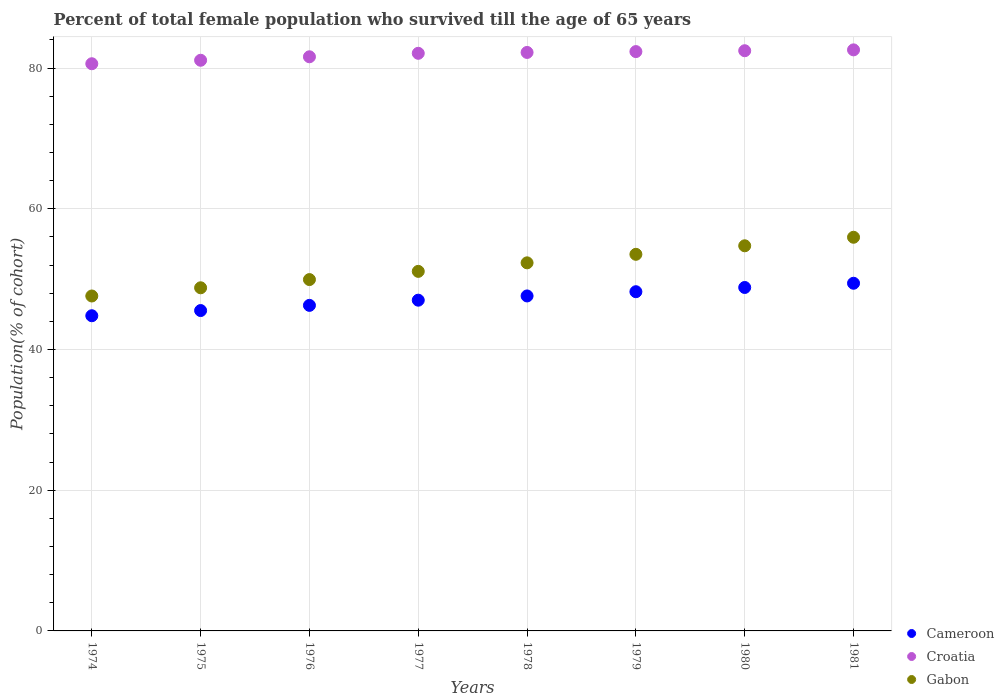Is the number of dotlines equal to the number of legend labels?
Offer a very short reply. Yes. What is the percentage of total female population who survived till the age of 65 years in Gabon in 1977?
Ensure brevity in your answer.  51.11. Across all years, what is the maximum percentage of total female population who survived till the age of 65 years in Gabon?
Your response must be concise. 55.96. Across all years, what is the minimum percentage of total female population who survived till the age of 65 years in Cameroon?
Offer a terse response. 44.8. In which year was the percentage of total female population who survived till the age of 65 years in Gabon maximum?
Give a very brief answer. 1981. In which year was the percentage of total female population who survived till the age of 65 years in Gabon minimum?
Ensure brevity in your answer.  1974. What is the total percentage of total female population who survived till the age of 65 years in Gabon in the graph?
Ensure brevity in your answer.  413.98. What is the difference between the percentage of total female population who survived till the age of 65 years in Croatia in 1978 and that in 1981?
Your response must be concise. -0.37. What is the difference between the percentage of total female population who survived till the age of 65 years in Croatia in 1975 and the percentage of total female population who survived till the age of 65 years in Cameroon in 1977?
Make the answer very short. 34.1. What is the average percentage of total female population who survived till the age of 65 years in Gabon per year?
Keep it short and to the point. 51.75. In the year 1978, what is the difference between the percentage of total female population who survived till the age of 65 years in Croatia and percentage of total female population who survived till the age of 65 years in Cameroon?
Your response must be concise. 34.61. What is the ratio of the percentage of total female population who survived till the age of 65 years in Cameroon in 1976 to that in 1981?
Provide a succinct answer. 0.94. Is the percentage of total female population who survived till the age of 65 years in Cameroon in 1978 less than that in 1980?
Keep it short and to the point. Yes. Is the difference between the percentage of total female population who survived till the age of 65 years in Croatia in 1976 and 1981 greater than the difference between the percentage of total female population who survived till the age of 65 years in Cameroon in 1976 and 1981?
Keep it short and to the point. Yes. What is the difference between the highest and the second highest percentage of total female population who survived till the age of 65 years in Gabon?
Keep it short and to the point. 1.21. What is the difference between the highest and the lowest percentage of total female population who survived till the age of 65 years in Cameroon?
Keep it short and to the point. 4.62. Is the sum of the percentage of total female population who survived till the age of 65 years in Gabon in 1976 and 1979 greater than the maximum percentage of total female population who survived till the age of 65 years in Croatia across all years?
Give a very brief answer. Yes. Is it the case that in every year, the sum of the percentage of total female population who survived till the age of 65 years in Croatia and percentage of total female population who survived till the age of 65 years in Cameroon  is greater than the percentage of total female population who survived till the age of 65 years in Gabon?
Your response must be concise. Yes. Does the percentage of total female population who survived till the age of 65 years in Cameroon monotonically increase over the years?
Your response must be concise. Yes. Are the values on the major ticks of Y-axis written in scientific E-notation?
Make the answer very short. No. Does the graph contain any zero values?
Provide a short and direct response. No. Does the graph contain grids?
Ensure brevity in your answer.  Yes. Where does the legend appear in the graph?
Your answer should be compact. Bottom right. How many legend labels are there?
Your response must be concise. 3. How are the legend labels stacked?
Keep it short and to the point. Vertical. What is the title of the graph?
Your answer should be compact. Percent of total female population who survived till the age of 65 years. What is the label or title of the Y-axis?
Make the answer very short. Population(% of cohort). What is the Population(% of cohort) in Cameroon in 1974?
Provide a succinct answer. 44.8. What is the Population(% of cohort) of Croatia in 1974?
Keep it short and to the point. 80.62. What is the Population(% of cohort) of Gabon in 1974?
Provide a succinct answer. 47.61. What is the Population(% of cohort) of Cameroon in 1975?
Keep it short and to the point. 45.54. What is the Population(% of cohort) of Croatia in 1975?
Offer a terse response. 81.11. What is the Population(% of cohort) in Gabon in 1975?
Your answer should be very brief. 48.77. What is the Population(% of cohort) in Cameroon in 1976?
Provide a short and direct response. 46.27. What is the Population(% of cohort) in Croatia in 1976?
Give a very brief answer. 81.61. What is the Population(% of cohort) in Gabon in 1976?
Keep it short and to the point. 49.94. What is the Population(% of cohort) in Cameroon in 1977?
Your answer should be compact. 47.01. What is the Population(% of cohort) of Croatia in 1977?
Provide a short and direct response. 82.1. What is the Population(% of cohort) in Gabon in 1977?
Offer a terse response. 51.11. What is the Population(% of cohort) in Cameroon in 1978?
Your answer should be compact. 47.61. What is the Population(% of cohort) in Croatia in 1978?
Provide a succinct answer. 82.23. What is the Population(% of cohort) in Gabon in 1978?
Make the answer very short. 52.32. What is the Population(% of cohort) in Cameroon in 1979?
Your response must be concise. 48.22. What is the Population(% of cohort) of Croatia in 1979?
Give a very brief answer. 82.35. What is the Population(% of cohort) in Gabon in 1979?
Offer a terse response. 53.53. What is the Population(% of cohort) of Cameroon in 1980?
Offer a terse response. 48.82. What is the Population(% of cohort) of Croatia in 1980?
Make the answer very short. 82.47. What is the Population(% of cohort) in Gabon in 1980?
Keep it short and to the point. 54.74. What is the Population(% of cohort) of Cameroon in 1981?
Offer a very short reply. 49.42. What is the Population(% of cohort) of Croatia in 1981?
Make the answer very short. 82.59. What is the Population(% of cohort) in Gabon in 1981?
Keep it short and to the point. 55.96. Across all years, what is the maximum Population(% of cohort) of Cameroon?
Offer a terse response. 49.42. Across all years, what is the maximum Population(% of cohort) in Croatia?
Your answer should be compact. 82.59. Across all years, what is the maximum Population(% of cohort) in Gabon?
Make the answer very short. 55.96. Across all years, what is the minimum Population(% of cohort) of Cameroon?
Keep it short and to the point. 44.8. Across all years, what is the minimum Population(% of cohort) in Croatia?
Provide a succinct answer. 80.62. Across all years, what is the minimum Population(% of cohort) of Gabon?
Offer a terse response. 47.61. What is the total Population(% of cohort) of Cameroon in the graph?
Ensure brevity in your answer.  377.69. What is the total Population(% of cohort) in Croatia in the graph?
Your answer should be very brief. 655.08. What is the total Population(% of cohort) in Gabon in the graph?
Give a very brief answer. 413.98. What is the difference between the Population(% of cohort) of Cameroon in 1974 and that in 1975?
Ensure brevity in your answer.  -0.74. What is the difference between the Population(% of cohort) of Croatia in 1974 and that in 1975?
Keep it short and to the point. -0.49. What is the difference between the Population(% of cohort) of Gabon in 1974 and that in 1975?
Offer a terse response. -1.17. What is the difference between the Population(% of cohort) of Cameroon in 1974 and that in 1976?
Provide a succinct answer. -1.47. What is the difference between the Population(% of cohort) of Croatia in 1974 and that in 1976?
Give a very brief answer. -0.99. What is the difference between the Population(% of cohort) of Gabon in 1974 and that in 1976?
Make the answer very short. -2.33. What is the difference between the Population(% of cohort) of Cameroon in 1974 and that in 1977?
Your response must be concise. -2.21. What is the difference between the Population(% of cohort) in Croatia in 1974 and that in 1977?
Provide a short and direct response. -1.48. What is the difference between the Population(% of cohort) of Gabon in 1974 and that in 1977?
Make the answer very short. -3.5. What is the difference between the Population(% of cohort) in Cameroon in 1974 and that in 1978?
Give a very brief answer. -2.81. What is the difference between the Population(% of cohort) in Croatia in 1974 and that in 1978?
Provide a short and direct response. -1.61. What is the difference between the Population(% of cohort) of Gabon in 1974 and that in 1978?
Offer a terse response. -4.71. What is the difference between the Population(% of cohort) of Cameroon in 1974 and that in 1979?
Give a very brief answer. -3.42. What is the difference between the Population(% of cohort) of Croatia in 1974 and that in 1979?
Provide a short and direct response. -1.73. What is the difference between the Population(% of cohort) of Gabon in 1974 and that in 1979?
Make the answer very short. -5.92. What is the difference between the Population(% of cohort) in Cameroon in 1974 and that in 1980?
Ensure brevity in your answer.  -4.02. What is the difference between the Population(% of cohort) of Croatia in 1974 and that in 1980?
Offer a very short reply. -1.85. What is the difference between the Population(% of cohort) in Gabon in 1974 and that in 1980?
Offer a terse response. -7.14. What is the difference between the Population(% of cohort) in Cameroon in 1974 and that in 1981?
Your answer should be very brief. -4.62. What is the difference between the Population(% of cohort) in Croatia in 1974 and that in 1981?
Offer a terse response. -1.97. What is the difference between the Population(% of cohort) of Gabon in 1974 and that in 1981?
Provide a short and direct response. -8.35. What is the difference between the Population(% of cohort) of Cameroon in 1975 and that in 1976?
Provide a succinct answer. -0.74. What is the difference between the Population(% of cohort) in Croatia in 1975 and that in 1976?
Your answer should be compact. -0.49. What is the difference between the Population(% of cohort) of Gabon in 1975 and that in 1976?
Your answer should be compact. -1.17. What is the difference between the Population(% of cohort) in Cameroon in 1975 and that in 1977?
Your response must be concise. -1.47. What is the difference between the Population(% of cohort) in Croatia in 1975 and that in 1977?
Your answer should be compact. -0.99. What is the difference between the Population(% of cohort) of Gabon in 1975 and that in 1977?
Ensure brevity in your answer.  -2.33. What is the difference between the Population(% of cohort) of Cameroon in 1975 and that in 1978?
Make the answer very short. -2.08. What is the difference between the Population(% of cohort) of Croatia in 1975 and that in 1978?
Your answer should be compact. -1.11. What is the difference between the Population(% of cohort) of Gabon in 1975 and that in 1978?
Make the answer very short. -3.55. What is the difference between the Population(% of cohort) of Cameroon in 1975 and that in 1979?
Provide a succinct answer. -2.68. What is the difference between the Population(% of cohort) in Croatia in 1975 and that in 1979?
Offer a terse response. -1.23. What is the difference between the Population(% of cohort) of Gabon in 1975 and that in 1979?
Provide a short and direct response. -4.76. What is the difference between the Population(% of cohort) in Cameroon in 1975 and that in 1980?
Your answer should be very brief. -3.28. What is the difference between the Population(% of cohort) of Croatia in 1975 and that in 1980?
Provide a succinct answer. -1.36. What is the difference between the Population(% of cohort) in Gabon in 1975 and that in 1980?
Keep it short and to the point. -5.97. What is the difference between the Population(% of cohort) in Cameroon in 1975 and that in 1981?
Provide a short and direct response. -3.88. What is the difference between the Population(% of cohort) of Croatia in 1975 and that in 1981?
Provide a short and direct response. -1.48. What is the difference between the Population(% of cohort) of Gabon in 1975 and that in 1981?
Keep it short and to the point. -7.18. What is the difference between the Population(% of cohort) of Cameroon in 1976 and that in 1977?
Give a very brief answer. -0.74. What is the difference between the Population(% of cohort) in Croatia in 1976 and that in 1977?
Make the answer very short. -0.49. What is the difference between the Population(% of cohort) of Gabon in 1976 and that in 1977?
Your response must be concise. -1.17. What is the difference between the Population(% of cohort) of Cameroon in 1976 and that in 1978?
Ensure brevity in your answer.  -1.34. What is the difference between the Population(% of cohort) in Croatia in 1976 and that in 1978?
Your response must be concise. -0.62. What is the difference between the Population(% of cohort) in Gabon in 1976 and that in 1978?
Your answer should be very brief. -2.38. What is the difference between the Population(% of cohort) of Cameroon in 1976 and that in 1979?
Your answer should be compact. -1.94. What is the difference between the Population(% of cohort) of Croatia in 1976 and that in 1979?
Your answer should be compact. -0.74. What is the difference between the Population(% of cohort) of Gabon in 1976 and that in 1979?
Ensure brevity in your answer.  -3.59. What is the difference between the Population(% of cohort) in Cameroon in 1976 and that in 1980?
Provide a succinct answer. -2.54. What is the difference between the Population(% of cohort) of Croatia in 1976 and that in 1980?
Your answer should be very brief. -0.86. What is the difference between the Population(% of cohort) of Gabon in 1976 and that in 1980?
Provide a succinct answer. -4.8. What is the difference between the Population(% of cohort) in Cameroon in 1976 and that in 1981?
Offer a very short reply. -3.14. What is the difference between the Population(% of cohort) in Croatia in 1976 and that in 1981?
Your answer should be compact. -0.98. What is the difference between the Population(% of cohort) in Gabon in 1976 and that in 1981?
Ensure brevity in your answer.  -6.01. What is the difference between the Population(% of cohort) of Cameroon in 1977 and that in 1978?
Offer a terse response. -0.6. What is the difference between the Population(% of cohort) of Croatia in 1977 and that in 1978?
Ensure brevity in your answer.  -0.12. What is the difference between the Population(% of cohort) of Gabon in 1977 and that in 1978?
Your answer should be compact. -1.21. What is the difference between the Population(% of cohort) of Cameroon in 1977 and that in 1979?
Your response must be concise. -1.2. What is the difference between the Population(% of cohort) in Croatia in 1977 and that in 1979?
Your response must be concise. -0.24. What is the difference between the Population(% of cohort) in Gabon in 1977 and that in 1979?
Provide a succinct answer. -2.42. What is the difference between the Population(% of cohort) of Cameroon in 1977 and that in 1980?
Your response must be concise. -1.8. What is the difference between the Population(% of cohort) in Croatia in 1977 and that in 1980?
Keep it short and to the point. -0.37. What is the difference between the Population(% of cohort) of Gabon in 1977 and that in 1980?
Offer a terse response. -3.64. What is the difference between the Population(% of cohort) in Cameroon in 1977 and that in 1981?
Keep it short and to the point. -2.41. What is the difference between the Population(% of cohort) in Croatia in 1977 and that in 1981?
Ensure brevity in your answer.  -0.49. What is the difference between the Population(% of cohort) in Gabon in 1977 and that in 1981?
Give a very brief answer. -4.85. What is the difference between the Population(% of cohort) of Cameroon in 1978 and that in 1979?
Provide a succinct answer. -0.6. What is the difference between the Population(% of cohort) of Croatia in 1978 and that in 1979?
Provide a succinct answer. -0.12. What is the difference between the Population(% of cohort) of Gabon in 1978 and that in 1979?
Your answer should be compact. -1.21. What is the difference between the Population(% of cohort) in Cameroon in 1978 and that in 1980?
Keep it short and to the point. -1.2. What is the difference between the Population(% of cohort) of Croatia in 1978 and that in 1980?
Give a very brief answer. -0.24. What is the difference between the Population(% of cohort) of Gabon in 1978 and that in 1980?
Your answer should be very brief. -2.42. What is the difference between the Population(% of cohort) in Cameroon in 1978 and that in 1981?
Make the answer very short. -1.8. What is the difference between the Population(% of cohort) in Croatia in 1978 and that in 1981?
Keep it short and to the point. -0.37. What is the difference between the Population(% of cohort) of Gabon in 1978 and that in 1981?
Provide a short and direct response. -3.64. What is the difference between the Population(% of cohort) in Cameroon in 1979 and that in 1980?
Your answer should be very brief. -0.6. What is the difference between the Population(% of cohort) in Croatia in 1979 and that in 1980?
Keep it short and to the point. -0.12. What is the difference between the Population(% of cohort) in Gabon in 1979 and that in 1980?
Your answer should be very brief. -1.21. What is the difference between the Population(% of cohort) in Cameroon in 1979 and that in 1981?
Ensure brevity in your answer.  -1.2. What is the difference between the Population(% of cohort) of Croatia in 1979 and that in 1981?
Give a very brief answer. -0.24. What is the difference between the Population(% of cohort) in Gabon in 1979 and that in 1981?
Keep it short and to the point. -2.42. What is the difference between the Population(% of cohort) of Cameroon in 1980 and that in 1981?
Offer a very short reply. -0.6. What is the difference between the Population(% of cohort) in Croatia in 1980 and that in 1981?
Your answer should be very brief. -0.12. What is the difference between the Population(% of cohort) of Gabon in 1980 and that in 1981?
Give a very brief answer. -1.21. What is the difference between the Population(% of cohort) of Cameroon in 1974 and the Population(% of cohort) of Croatia in 1975?
Give a very brief answer. -36.31. What is the difference between the Population(% of cohort) in Cameroon in 1974 and the Population(% of cohort) in Gabon in 1975?
Offer a terse response. -3.97. What is the difference between the Population(% of cohort) of Croatia in 1974 and the Population(% of cohort) of Gabon in 1975?
Make the answer very short. 31.85. What is the difference between the Population(% of cohort) in Cameroon in 1974 and the Population(% of cohort) in Croatia in 1976?
Offer a very short reply. -36.81. What is the difference between the Population(% of cohort) in Cameroon in 1974 and the Population(% of cohort) in Gabon in 1976?
Make the answer very short. -5.14. What is the difference between the Population(% of cohort) of Croatia in 1974 and the Population(% of cohort) of Gabon in 1976?
Your response must be concise. 30.68. What is the difference between the Population(% of cohort) of Cameroon in 1974 and the Population(% of cohort) of Croatia in 1977?
Ensure brevity in your answer.  -37.3. What is the difference between the Population(% of cohort) of Cameroon in 1974 and the Population(% of cohort) of Gabon in 1977?
Your answer should be very brief. -6.31. What is the difference between the Population(% of cohort) of Croatia in 1974 and the Population(% of cohort) of Gabon in 1977?
Offer a terse response. 29.51. What is the difference between the Population(% of cohort) of Cameroon in 1974 and the Population(% of cohort) of Croatia in 1978?
Provide a succinct answer. -37.43. What is the difference between the Population(% of cohort) in Cameroon in 1974 and the Population(% of cohort) in Gabon in 1978?
Give a very brief answer. -7.52. What is the difference between the Population(% of cohort) in Croatia in 1974 and the Population(% of cohort) in Gabon in 1978?
Your answer should be very brief. 28.3. What is the difference between the Population(% of cohort) of Cameroon in 1974 and the Population(% of cohort) of Croatia in 1979?
Your answer should be compact. -37.55. What is the difference between the Population(% of cohort) of Cameroon in 1974 and the Population(% of cohort) of Gabon in 1979?
Your response must be concise. -8.73. What is the difference between the Population(% of cohort) in Croatia in 1974 and the Population(% of cohort) in Gabon in 1979?
Make the answer very short. 27.09. What is the difference between the Population(% of cohort) in Cameroon in 1974 and the Population(% of cohort) in Croatia in 1980?
Ensure brevity in your answer.  -37.67. What is the difference between the Population(% of cohort) in Cameroon in 1974 and the Population(% of cohort) in Gabon in 1980?
Your answer should be compact. -9.94. What is the difference between the Population(% of cohort) of Croatia in 1974 and the Population(% of cohort) of Gabon in 1980?
Offer a very short reply. 25.88. What is the difference between the Population(% of cohort) in Cameroon in 1974 and the Population(% of cohort) in Croatia in 1981?
Make the answer very short. -37.79. What is the difference between the Population(% of cohort) of Cameroon in 1974 and the Population(% of cohort) of Gabon in 1981?
Provide a short and direct response. -11.16. What is the difference between the Population(% of cohort) of Croatia in 1974 and the Population(% of cohort) of Gabon in 1981?
Give a very brief answer. 24.66. What is the difference between the Population(% of cohort) of Cameroon in 1975 and the Population(% of cohort) of Croatia in 1976?
Your answer should be very brief. -36.07. What is the difference between the Population(% of cohort) in Cameroon in 1975 and the Population(% of cohort) in Gabon in 1976?
Provide a short and direct response. -4.4. What is the difference between the Population(% of cohort) of Croatia in 1975 and the Population(% of cohort) of Gabon in 1976?
Keep it short and to the point. 31.17. What is the difference between the Population(% of cohort) in Cameroon in 1975 and the Population(% of cohort) in Croatia in 1977?
Offer a very short reply. -36.57. What is the difference between the Population(% of cohort) of Cameroon in 1975 and the Population(% of cohort) of Gabon in 1977?
Ensure brevity in your answer.  -5.57. What is the difference between the Population(% of cohort) in Croatia in 1975 and the Population(% of cohort) in Gabon in 1977?
Provide a succinct answer. 30.01. What is the difference between the Population(% of cohort) in Cameroon in 1975 and the Population(% of cohort) in Croatia in 1978?
Offer a very short reply. -36.69. What is the difference between the Population(% of cohort) in Cameroon in 1975 and the Population(% of cohort) in Gabon in 1978?
Give a very brief answer. -6.78. What is the difference between the Population(% of cohort) in Croatia in 1975 and the Population(% of cohort) in Gabon in 1978?
Ensure brevity in your answer.  28.8. What is the difference between the Population(% of cohort) of Cameroon in 1975 and the Population(% of cohort) of Croatia in 1979?
Provide a short and direct response. -36.81. What is the difference between the Population(% of cohort) of Cameroon in 1975 and the Population(% of cohort) of Gabon in 1979?
Provide a short and direct response. -7.99. What is the difference between the Population(% of cohort) in Croatia in 1975 and the Population(% of cohort) in Gabon in 1979?
Make the answer very short. 27.58. What is the difference between the Population(% of cohort) in Cameroon in 1975 and the Population(% of cohort) in Croatia in 1980?
Provide a succinct answer. -36.93. What is the difference between the Population(% of cohort) of Cameroon in 1975 and the Population(% of cohort) of Gabon in 1980?
Your answer should be compact. -9.21. What is the difference between the Population(% of cohort) of Croatia in 1975 and the Population(% of cohort) of Gabon in 1980?
Your answer should be very brief. 26.37. What is the difference between the Population(% of cohort) in Cameroon in 1975 and the Population(% of cohort) in Croatia in 1981?
Offer a very short reply. -37.05. What is the difference between the Population(% of cohort) in Cameroon in 1975 and the Population(% of cohort) in Gabon in 1981?
Keep it short and to the point. -10.42. What is the difference between the Population(% of cohort) of Croatia in 1975 and the Population(% of cohort) of Gabon in 1981?
Make the answer very short. 25.16. What is the difference between the Population(% of cohort) of Cameroon in 1976 and the Population(% of cohort) of Croatia in 1977?
Make the answer very short. -35.83. What is the difference between the Population(% of cohort) of Cameroon in 1976 and the Population(% of cohort) of Gabon in 1977?
Offer a very short reply. -4.83. What is the difference between the Population(% of cohort) in Croatia in 1976 and the Population(% of cohort) in Gabon in 1977?
Offer a very short reply. 30.5. What is the difference between the Population(% of cohort) of Cameroon in 1976 and the Population(% of cohort) of Croatia in 1978?
Your answer should be very brief. -35.95. What is the difference between the Population(% of cohort) of Cameroon in 1976 and the Population(% of cohort) of Gabon in 1978?
Ensure brevity in your answer.  -6.04. What is the difference between the Population(% of cohort) of Croatia in 1976 and the Population(% of cohort) of Gabon in 1978?
Ensure brevity in your answer.  29.29. What is the difference between the Population(% of cohort) in Cameroon in 1976 and the Population(% of cohort) in Croatia in 1979?
Provide a short and direct response. -36.07. What is the difference between the Population(% of cohort) of Cameroon in 1976 and the Population(% of cohort) of Gabon in 1979?
Keep it short and to the point. -7.26. What is the difference between the Population(% of cohort) of Croatia in 1976 and the Population(% of cohort) of Gabon in 1979?
Give a very brief answer. 28.08. What is the difference between the Population(% of cohort) of Cameroon in 1976 and the Population(% of cohort) of Croatia in 1980?
Provide a succinct answer. -36.2. What is the difference between the Population(% of cohort) in Cameroon in 1976 and the Population(% of cohort) in Gabon in 1980?
Give a very brief answer. -8.47. What is the difference between the Population(% of cohort) of Croatia in 1976 and the Population(% of cohort) of Gabon in 1980?
Offer a very short reply. 26.87. What is the difference between the Population(% of cohort) of Cameroon in 1976 and the Population(% of cohort) of Croatia in 1981?
Provide a succinct answer. -36.32. What is the difference between the Population(% of cohort) of Cameroon in 1976 and the Population(% of cohort) of Gabon in 1981?
Your answer should be compact. -9.68. What is the difference between the Population(% of cohort) of Croatia in 1976 and the Population(% of cohort) of Gabon in 1981?
Your response must be concise. 25.65. What is the difference between the Population(% of cohort) of Cameroon in 1977 and the Population(% of cohort) of Croatia in 1978?
Provide a succinct answer. -35.21. What is the difference between the Population(% of cohort) of Cameroon in 1977 and the Population(% of cohort) of Gabon in 1978?
Provide a succinct answer. -5.31. What is the difference between the Population(% of cohort) in Croatia in 1977 and the Population(% of cohort) in Gabon in 1978?
Your response must be concise. 29.78. What is the difference between the Population(% of cohort) in Cameroon in 1977 and the Population(% of cohort) in Croatia in 1979?
Offer a very short reply. -35.34. What is the difference between the Population(% of cohort) of Cameroon in 1977 and the Population(% of cohort) of Gabon in 1979?
Your answer should be very brief. -6.52. What is the difference between the Population(% of cohort) in Croatia in 1977 and the Population(% of cohort) in Gabon in 1979?
Your answer should be very brief. 28.57. What is the difference between the Population(% of cohort) of Cameroon in 1977 and the Population(% of cohort) of Croatia in 1980?
Offer a terse response. -35.46. What is the difference between the Population(% of cohort) in Cameroon in 1977 and the Population(% of cohort) in Gabon in 1980?
Keep it short and to the point. -7.73. What is the difference between the Population(% of cohort) of Croatia in 1977 and the Population(% of cohort) of Gabon in 1980?
Your answer should be very brief. 27.36. What is the difference between the Population(% of cohort) in Cameroon in 1977 and the Population(% of cohort) in Croatia in 1981?
Provide a short and direct response. -35.58. What is the difference between the Population(% of cohort) of Cameroon in 1977 and the Population(% of cohort) of Gabon in 1981?
Your answer should be compact. -8.94. What is the difference between the Population(% of cohort) in Croatia in 1977 and the Population(% of cohort) in Gabon in 1981?
Provide a succinct answer. 26.15. What is the difference between the Population(% of cohort) of Cameroon in 1978 and the Population(% of cohort) of Croatia in 1979?
Offer a terse response. -34.73. What is the difference between the Population(% of cohort) in Cameroon in 1978 and the Population(% of cohort) in Gabon in 1979?
Your answer should be compact. -5.92. What is the difference between the Population(% of cohort) in Croatia in 1978 and the Population(% of cohort) in Gabon in 1979?
Provide a succinct answer. 28.69. What is the difference between the Population(% of cohort) of Cameroon in 1978 and the Population(% of cohort) of Croatia in 1980?
Give a very brief answer. -34.86. What is the difference between the Population(% of cohort) of Cameroon in 1978 and the Population(% of cohort) of Gabon in 1980?
Your response must be concise. -7.13. What is the difference between the Population(% of cohort) in Croatia in 1978 and the Population(% of cohort) in Gabon in 1980?
Ensure brevity in your answer.  27.48. What is the difference between the Population(% of cohort) in Cameroon in 1978 and the Population(% of cohort) in Croatia in 1981?
Your answer should be very brief. -34.98. What is the difference between the Population(% of cohort) in Cameroon in 1978 and the Population(% of cohort) in Gabon in 1981?
Provide a succinct answer. -8.34. What is the difference between the Population(% of cohort) of Croatia in 1978 and the Population(% of cohort) of Gabon in 1981?
Keep it short and to the point. 26.27. What is the difference between the Population(% of cohort) of Cameroon in 1979 and the Population(% of cohort) of Croatia in 1980?
Your response must be concise. -34.25. What is the difference between the Population(% of cohort) in Cameroon in 1979 and the Population(% of cohort) in Gabon in 1980?
Ensure brevity in your answer.  -6.53. What is the difference between the Population(% of cohort) in Croatia in 1979 and the Population(% of cohort) in Gabon in 1980?
Your response must be concise. 27.6. What is the difference between the Population(% of cohort) of Cameroon in 1979 and the Population(% of cohort) of Croatia in 1981?
Provide a short and direct response. -34.38. What is the difference between the Population(% of cohort) in Cameroon in 1979 and the Population(% of cohort) in Gabon in 1981?
Provide a short and direct response. -7.74. What is the difference between the Population(% of cohort) of Croatia in 1979 and the Population(% of cohort) of Gabon in 1981?
Provide a short and direct response. 26.39. What is the difference between the Population(% of cohort) in Cameroon in 1980 and the Population(% of cohort) in Croatia in 1981?
Offer a terse response. -33.77. What is the difference between the Population(% of cohort) of Cameroon in 1980 and the Population(% of cohort) of Gabon in 1981?
Make the answer very short. -7.14. What is the difference between the Population(% of cohort) of Croatia in 1980 and the Population(% of cohort) of Gabon in 1981?
Provide a succinct answer. 26.51. What is the average Population(% of cohort) of Cameroon per year?
Provide a short and direct response. 47.21. What is the average Population(% of cohort) in Croatia per year?
Offer a terse response. 81.89. What is the average Population(% of cohort) in Gabon per year?
Keep it short and to the point. 51.75. In the year 1974, what is the difference between the Population(% of cohort) of Cameroon and Population(% of cohort) of Croatia?
Ensure brevity in your answer.  -35.82. In the year 1974, what is the difference between the Population(% of cohort) of Cameroon and Population(% of cohort) of Gabon?
Provide a short and direct response. -2.81. In the year 1974, what is the difference between the Population(% of cohort) of Croatia and Population(% of cohort) of Gabon?
Make the answer very short. 33.01. In the year 1975, what is the difference between the Population(% of cohort) of Cameroon and Population(% of cohort) of Croatia?
Ensure brevity in your answer.  -35.58. In the year 1975, what is the difference between the Population(% of cohort) of Cameroon and Population(% of cohort) of Gabon?
Keep it short and to the point. -3.24. In the year 1975, what is the difference between the Population(% of cohort) of Croatia and Population(% of cohort) of Gabon?
Keep it short and to the point. 32.34. In the year 1976, what is the difference between the Population(% of cohort) of Cameroon and Population(% of cohort) of Croatia?
Make the answer very short. -35.33. In the year 1976, what is the difference between the Population(% of cohort) in Cameroon and Population(% of cohort) in Gabon?
Your response must be concise. -3.67. In the year 1976, what is the difference between the Population(% of cohort) in Croatia and Population(% of cohort) in Gabon?
Offer a terse response. 31.67. In the year 1977, what is the difference between the Population(% of cohort) in Cameroon and Population(% of cohort) in Croatia?
Ensure brevity in your answer.  -35.09. In the year 1977, what is the difference between the Population(% of cohort) of Cameroon and Population(% of cohort) of Gabon?
Provide a short and direct response. -4.1. In the year 1977, what is the difference between the Population(% of cohort) in Croatia and Population(% of cohort) in Gabon?
Offer a terse response. 31. In the year 1978, what is the difference between the Population(% of cohort) in Cameroon and Population(% of cohort) in Croatia?
Offer a terse response. -34.61. In the year 1978, what is the difference between the Population(% of cohort) in Cameroon and Population(% of cohort) in Gabon?
Keep it short and to the point. -4.71. In the year 1978, what is the difference between the Population(% of cohort) of Croatia and Population(% of cohort) of Gabon?
Provide a short and direct response. 29.91. In the year 1979, what is the difference between the Population(% of cohort) in Cameroon and Population(% of cohort) in Croatia?
Give a very brief answer. -34.13. In the year 1979, what is the difference between the Population(% of cohort) in Cameroon and Population(% of cohort) in Gabon?
Keep it short and to the point. -5.32. In the year 1979, what is the difference between the Population(% of cohort) of Croatia and Population(% of cohort) of Gabon?
Your answer should be very brief. 28.82. In the year 1980, what is the difference between the Population(% of cohort) in Cameroon and Population(% of cohort) in Croatia?
Give a very brief answer. -33.65. In the year 1980, what is the difference between the Population(% of cohort) in Cameroon and Population(% of cohort) in Gabon?
Your answer should be very brief. -5.93. In the year 1980, what is the difference between the Population(% of cohort) in Croatia and Population(% of cohort) in Gabon?
Give a very brief answer. 27.73. In the year 1981, what is the difference between the Population(% of cohort) of Cameroon and Population(% of cohort) of Croatia?
Offer a terse response. -33.17. In the year 1981, what is the difference between the Population(% of cohort) in Cameroon and Population(% of cohort) in Gabon?
Your answer should be very brief. -6.54. In the year 1981, what is the difference between the Population(% of cohort) in Croatia and Population(% of cohort) in Gabon?
Provide a short and direct response. 26.64. What is the ratio of the Population(% of cohort) of Cameroon in 1974 to that in 1975?
Your answer should be compact. 0.98. What is the ratio of the Population(% of cohort) in Croatia in 1974 to that in 1975?
Provide a succinct answer. 0.99. What is the ratio of the Population(% of cohort) in Gabon in 1974 to that in 1975?
Your response must be concise. 0.98. What is the ratio of the Population(% of cohort) of Cameroon in 1974 to that in 1976?
Your response must be concise. 0.97. What is the ratio of the Population(% of cohort) of Croatia in 1974 to that in 1976?
Your response must be concise. 0.99. What is the ratio of the Population(% of cohort) in Gabon in 1974 to that in 1976?
Your response must be concise. 0.95. What is the ratio of the Population(% of cohort) of Cameroon in 1974 to that in 1977?
Your response must be concise. 0.95. What is the ratio of the Population(% of cohort) in Croatia in 1974 to that in 1977?
Make the answer very short. 0.98. What is the ratio of the Population(% of cohort) of Gabon in 1974 to that in 1977?
Your response must be concise. 0.93. What is the ratio of the Population(% of cohort) of Cameroon in 1974 to that in 1978?
Keep it short and to the point. 0.94. What is the ratio of the Population(% of cohort) of Croatia in 1974 to that in 1978?
Provide a short and direct response. 0.98. What is the ratio of the Population(% of cohort) of Gabon in 1974 to that in 1978?
Offer a very short reply. 0.91. What is the ratio of the Population(% of cohort) in Cameroon in 1974 to that in 1979?
Make the answer very short. 0.93. What is the ratio of the Population(% of cohort) of Croatia in 1974 to that in 1979?
Provide a short and direct response. 0.98. What is the ratio of the Population(% of cohort) in Gabon in 1974 to that in 1979?
Ensure brevity in your answer.  0.89. What is the ratio of the Population(% of cohort) of Cameroon in 1974 to that in 1980?
Keep it short and to the point. 0.92. What is the ratio of the Population(% of cohort) in Croatia in 1974 to that in 1980?
Make the answer very short. 0.98. What is the ratio of the Population(% of cohort) of Gabon in 1974 to that in 1980?
Your answer should be very brief. 0.87. What is the ratio of the Population(% of cohort) in Cameroon in 1974 to that in 1981?
Offer a very short reply. 0.91. What is the ratio of the Population(% of cohort) in Croatia in 1974 to that in 1981?
Give a very brief answer. 0.98. What is the ratio of the Population(% of cohort) in Gabon in 1974 to that in 1981?
Offer a terse response. 0.85. What is the ratio of the Population(% of cohort) of Cameroon in 1975 to that in 1976?
Offer a very short reply. 0.98. What is the ratio of the Population(% of cohort) of Gabon in 1975 to that in 1976?
Provide a short and direct response. 0.98. What is the ratio of the Population(% of cohort) of Cameroon in 1975 to that in 1977?
Provide a succinct answer. 0.97. What is the ratio of the Population(% of cohort) of Gabon in 1975 to that in 1977?
Offer a very short reply. 0.95. What is the ratio of the Population(% of cohort) of Cameroon in 1975 to that in 1978?
Your answer should be very brief. 0.96. What is the ratio of the Population(% of cohort) of Croatia in 1975 to that in 1978?
Your answer should be very brief. 0.99. What is the ratio of the Population(% of cohort) in Gabon in 1975 to that in 1978?
Your response must be concise. 0.93. What is the ratio of the Population(% of cohort) in Cameroon in 1975 to that in 1979?
Provide a succinct answer. 0.94. What is the ratio of the Population(% of cohort) of Croatia in 1975 to that in 1979?
Your answer should be compact. 0.98. What is the ratio of the Population(% of cohort) of Gabon in 1975 to that in 1979?
Ensure brevity in your answer.  0.91. What is the ratio of the Population(% of cohort) of Cameroon in 1975 to that in 1980?
Give a very brief answer. 0.93. What is the ratio of the Population(% of cohort) of Croatia in 1975 to that in 1980?
Your response must be concise. 0.98. What is the ratio of the Population(% of cohort) of Gabon in 1975 to that in 1980?
Make the answer very short. 0.89. What is the ratio of the Population(% of cohort) of Cameroon in 1975 to that in 1981?
Your response must be concise. 0.92. What is the ratio of the Population(% of cohort) of Croatia in 1975 to that in 1981?
Offer a very short reply. 0.98. What is the ratio of the Population(% of cohort) of Gabon in 1975 to that in 1981?
Give a very brief answer. 0.87. What is the ratio of the Population(% of cohort) in Cameroon in 1976 to that in 1977?
Make the answer very short. 0.98. What is the ratio of the Population(% of cohort) of Gabon in 1976 to that in 1977?
Make the answer very short. 0.98. What is the ratio of the Population(% of cohort) in Cameroon in 1976 to that in 1978?
Give a very brief answer. 0.97. What is the ratio of the Population(% of cohort) of Gabon in 1976 to that in 1978?
Your answer should be very brief. 0.95. What is the ratio of the Population(% of cohort) of Cameroon in 1976 to that in 1979?
Offer a terse response. 0.96. What is the ratio of the Population(% of cohort) of Croatia in 1976 to that in 1979?
Provide a succinct answer. 0.99. What is the ratio of the Population(% of cohort) of Gabon in 1976 to that in 1979?
Give a very brief answer. 0.93. What is the ratio of the Population(% of cohort) in Cameroon in 1976 to that in 1980?
Keep it short and to the point. 0.95. What is the ratio of the Population(% of cohort) of Gabon in 1976 to that in 1980?
Make the answer very short. 0.91. What is the ratio of the Population(% of cohort) of Cameroon in 1976 to that in 1981?
Offer a very short reply. 0.94. What is the ratio of the Population(% of cohort) in Croatia in 1976 to that in 1981?
Provide a succinct answer. 0.99. What is the ratio of the Population(% of cohort) in Gabon in 1976 to that in 1981?
Offer a very short reply. 0.89. What is the ratio of the Population(% of cohort) of Cameroon in 1977 to that in 1978?
Offer a terse response. 0.99. What is the ratio of the Population(% of cohort) of Gabon in 1977 to that in 1978?
Your answer should be very brief. 0.98. What is the ratio of the Population(% of cohort) of Cameroon in 1977 to that in 1979?
Give a very brief answer. 0.97. What is the ratio of the Population(% of cohort) of Croatia in 1977 to that in 1979?
Make the answer very short. 1. What is the ratio of the Population(% of cohort) of Gabon in 1977 to that in 1979?
Ensure brevity in your answer.  0.95. What is the ratio of the Population(% of cohort) of Cameroon in 1977 to that in 1980?
Make the answer very short. 0.96. What is the ratio of the Population(% of cohort) in Gabon in 1977 to that in 1980?
Your answer should be compact. 0.93. What is the ratio of the Population(% of cohort) in Cameroon in 1977 to that in 1981?
Provide a short and direct response. 0.95. What is the ratio of the Population(% of cohort) in Gabon in 1977 to that in 1981?
Your response must be concise. 0.91. What is the ratio of the Population(% of cohort) in Cameroon in 1978 to that in 1979?
Ensure brevity in your answer.  0.99. What is the ratio of the Population(% of cohort) of Gabon in 1978 to that in 1979?
Your response must be concise. 0.98. What is the ratio of the Population(% of cohort) of Cameroon in 1978 to that in 1980?
Make the answer very short. 0.98. What is the ratio of the Population(% of cohort) in Gabon in 1978 to that in 1980?
Make the answer very short. 0.96. What is the ratio of the Population(% of cohort) in Cameroon in 1978 to that in 1981?
Your answer should be compact. 0.96. What is the ratio of the Population(% of cohort) of Gabon in 1978 to that in 1981?
Your answer should be very brief. 0.94. What is the ratio of the Population(% of cohort) of Cameroon in 1979 to that in 1980?
Ensure brevity in your answer.  0.99. What is the ratio of the Population(% of cohort) in Croatia in 1979 to that in 1980?
Ensure brevity in your answer.  1. What is the ratio of the Population(% of cohort) of Gabon in 1979 to that in 1980?
Make the answer very short. 0.98. What is the ratio of the Population(% of cohort) in Cameroon in 1979 to that in 1981?
Ensure brevity in your answer.  0.98. What is the ratio of the Population(% of cohort) in Croatia in 1979 to that in 1981?
Ensure brevity in your answer.  1. What is the ratio of the Population(% of cohort) in Gabon in 1979 to that in 1981?
Make the answer very short. 0.96. What is the ratio of the Population(% of cohort) in Cameroon in 1980 to that in 1981?
Keep it short and to the point. 0.99. What is the ratio of the Population(% of cohort) of Gabon in 1980 to that in 1981?
Provide a succinct answer. 0.98. What is the difference between the highest and the second highest Population(% of cohort) of Cameroon?
Your answer should be very brief. 0.6. What is the difference between the highest and the second highest Population(% of cohort) of Croatia?
Ensure brevity in your answer.  0.12. What is the difference between the highest and the second highest Population(% of cohort) in Gabon?
Provide a succinct answer. 1.21. What is the difference between the highest and the lowest Population(% of cohort) of Cameroon?
Keep it short and to the point. 4.62. What is the difference between the highest and the lowest Population(% of cohort) in Croatia?
Offer a very short reply. 1.97. What is the difference between the highest and the lowest Population(% of cohort) of Gabon?
Keep it short and to the point. 8.35. 